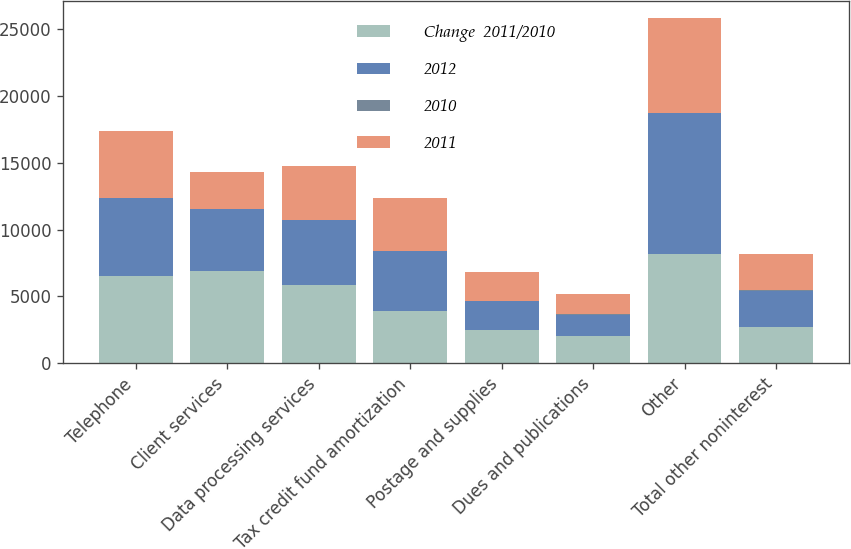Convert chart. <chart><loc_0><loc_0><loc_500><loc_500><stacked_bar_chart><ecel><fcel>Telephone<fcel>Client services<fcel>Data processing services<fcel>Tax credit fund amortization<fcel>Postage and supplies<fcel>Dues and publications<fcel>Other<fcel>Total other noninterest<nl><fcel>Change  2011/2010<fcel>6528<fcel>6910<fcel>5876<fcel>3911<fcel>2482<fcel>2067<fcel>8188<fcel>2716<nl><fcel>2012<fcel>5835<fcel>4594<fcel>4811<fcel>4474<fcel>2162<fcel>1570<fcel>10499<fcel>2716<nl><fcel>2010<fcel>11.9<fcel>50.4<fcel>22.1<fcel>12.6<fcel>14.8<fcel>31.7<fcel>22<fcel>16.7<nl><fcel>2011<fcel>4952<fcel>2716<fcel>4060<fcel>3965<fcel>2198<fcel>1519<fcel>7081<fcel>2716<nl></chart> 